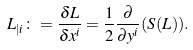Convert formula to latex. <formula><loc_0><loc_0><loc_500><loc_500>L _ { | i } \colon = \frac { \delta L } { \delta x ^ { i } } = \frac { 1 } { 2 } \frac { \partial } { \partial y ^ { i } } ( S ( L ) ) .</formula> 